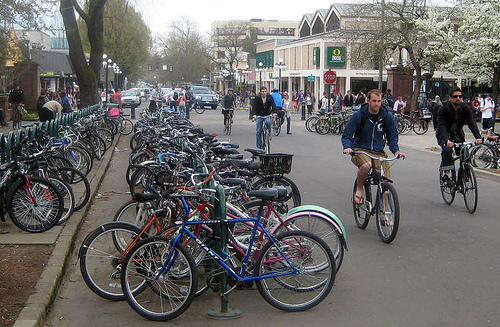Please extract the text content from this image. 0 